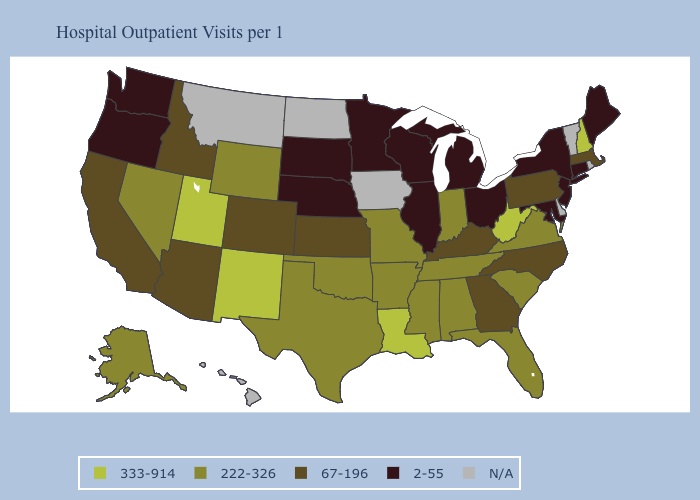What is the value of Nevada?
Quick response, please. 222-326. What is the value of Hawaii?
Quick response, please. N/A. What is the value of Tennessee?
Give a very brief answer. 222-326. Name the states that have a value in the range 67-196?
Write a very short answer. Arizona, California, Colorado, Georgia, Idaho, Kansas, Kentucky, Massachusetts, North Carolina, Pennsylvania. Name the states that have a value in the range N/A?
Keep it brief. Delaware, Hawaii, Iowa, Montana, North Dakota, Rhode Island, Vermont. What is the lowest value in states that border Maine?
Concise answer only. 333-914. Does Nevada have the highest value in the West?
Give a very brief answer. No. What is the lowest value in the Northeast?
Give a very brief answer. 2-55. Which states have the highest value in the USA?
Give a very brief answer. Louisiana, New Hampshire, New Mexico, Utah, West Virginia. Name the states that have a value in the range 222-326?
Be succinct. Alabama, Alaska, Arkansas, Florida, Indiana, Mississippi, Missouri, Nevada, Oklahoma, South Carolina, Tennessee, Texas, Virginia, Wyoming. Name the states that have a value in the range N/A?
Be succinct. Delaware, Hawaii, Iowa, Montana, North Dakota, Rhode Island, Vermont. Name the states that have a value in the range N/A?
Answer briefly. Delaware, Hawaii, Iowa, Montana, North Dakota, Rhode Island, Vermont. Among the states that border Kansas , which have the highest value?
Write a very short answer. Missouri, Oklahoma. What is the value of South Dakota?
Quick response, please. 2-55. 